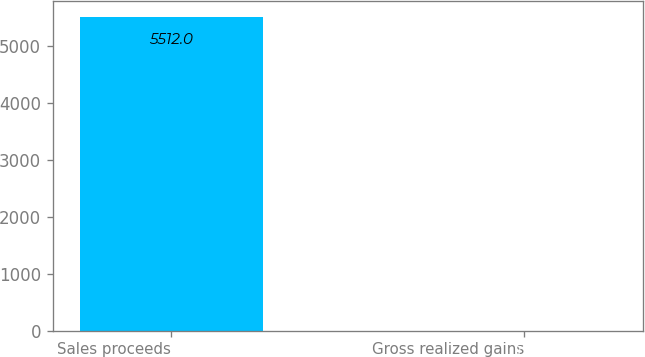Convert chart to OTSL. <chart><loc_0><loc_0><loc_500><loc_500><bar_chart><fcel>Sales proceeds<fcel>Gross realized gains<nl><fcel>5512<fcel>1<nl></chart> 